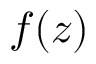<formula> <loc_0><loc_0><loc_500><loc_500>f ( z )</formula> 